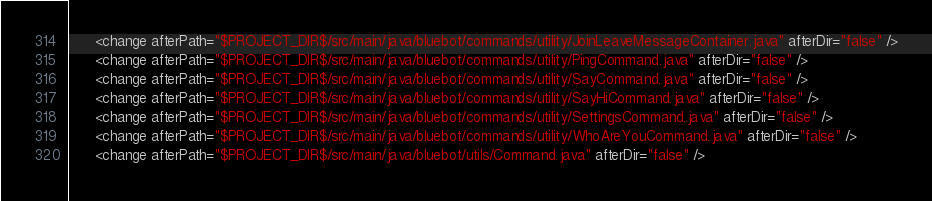Convert code to text. <code><loc_0><loc_0><loc_500><loc_500><_XML_>      <change afterPath="$PROJECT_DIR$/src/main/java/bluebot/commands/utility/JoinLeaveMessageContainer.java" afterDir="false" />
      <change afterPath="$PROJECT_DIR$/src/main/java/bluebot/commands/utility/PingCommand.java" afterDir="false" />
      <change afterPath="$PROJECT_DIR$/src/main/java/bluebot/commands/utility/SayCommand.java" afterDir="false" />
      <change afterPath="$PROJECT_DIR$/src/main/java/bluebot/commands/utility/SayHiCommand.java" afterDir="false" />
      <change afterPath="$PROJECT_DIR$/src/main/java/bluebot/commands/utility/SettingsCommand.java" afterDir="false" />
      <change afterPath="$PROJECT_DIR$/src/main/java/bluebot/commands/utility/WhoAreYouCommand.java" afterDir="false" />
      <change afterPath="$PROJECT_DIR$/src/main/java/bluebot/utils/Command.java" afterDir="false" /></code> 